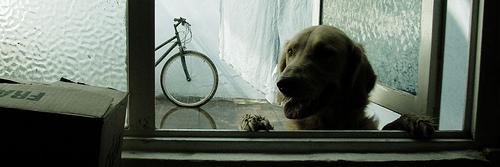Is there an animal in the image?
Short answer required. Yes. Does the animal want to go out or in?
Quick response, please. In. Is the ground outside wet?
Short answer required. Yes. 